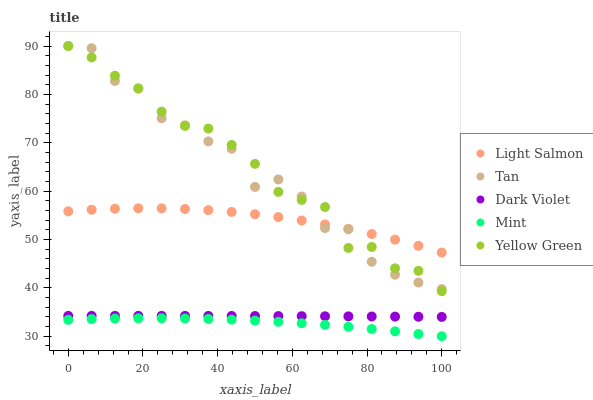Does Mint have the minimum area under the curve?
Answer yes or no. Yes. Does Yellow Green have the maximum area under the curve?
Answer yes or no. Yes. Does Tan have the minimum area under the curve?
Answer yes or no. No. Does Tan have the maximum area under the curve?
Answer yes or no. No. Is Dark Violet the smoothest?
Answer yes or no. Yes. Is Tan the roughest?
Answer yes or no. Yes. Is Mint the smoothest?
Answer yes or no. No. Is Mint the roughest?
Answer yes or no. No. Does Mint have the lowest value?
Answer yes or no. Yes. Does Tan have the lowest value?
Answer yes or no. No. Does Yellow Green have the highest value?
Answer yes or no. Yes. Does Mint have the highest value?
Answer yes or no. No. Is Dark Violet less than Yellow Green?
Answer yes or no. Yes. Is Dark Violet greater than Mint?
Answer yes or no. Yes. Does Tan intersect Yellow Green?
Answer yes or no. Yes. Is Tan less than Yellow Green?
Answer yes or no. No. Is Tan greater than Yellow Green?
Answer yes or no. No. Does Dark Violet intersect Yellow Green?
Answer yes or no. No. 